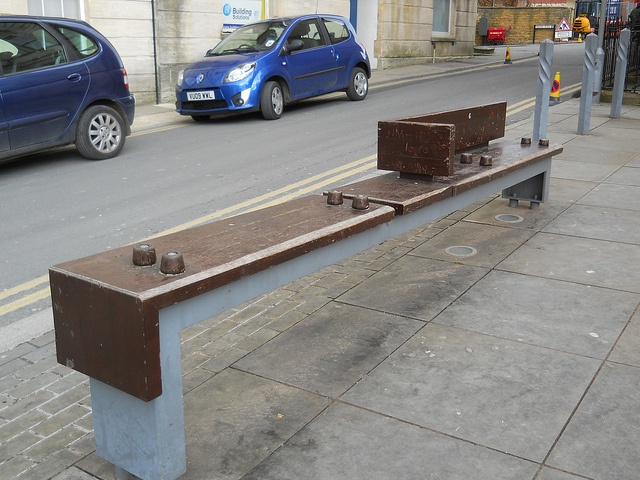Describe the objects in this image and their specific colors. I can see bench in beige, darkgray, black, and gray tones, car in beige, navy, purple, black, and darkblue tones, and car in beige, black, gray, navy, and darkgray tones in this image. 